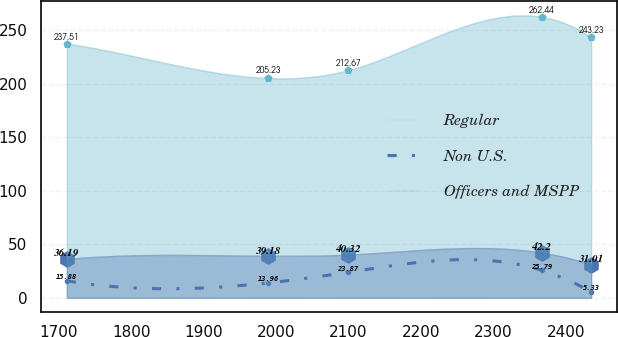Convert chart to OTSL. <chart><loc_0><loc_0><loc_500><loc_500><line_chart><ecel><fcel>Regular<fcel>Non U.S.<fcel>Officers and MSPP<nl><fcel>1711.01<fcel>237.51<fcel>15.88<fcel>36.19<nl><fcel>1989.3<fcel>205.23<fcel>13.96<fcel>39.18<nl><fcel>2099.41<fcel>212.67<fcel>23.87<fcel>40.32<nl><fcel>2366.4<fcel>262.44<fcel>25.79<fcel>42.2<nl><fcel>2434.87<fcel>243.23<fcel>5.33<fcel>31.01<nl></chart> 